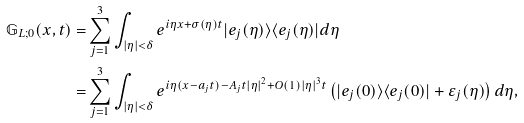<formula> <loc_0><loc_0><loc_500><loc_500>\mathbb { G } _ { L ; 0 } ( x , t ) = & \sum _ { j = 1 } ^ { 3 } \int _ { | \eta | < \delta } e ^ { i \eta x + \sigma ( \eta ) t } | e _ { j } ( \eta ) \rangle \langle e _ { j } ( \eta ) | d \eta \\ = & \sum _ { j = 1 } ^ { 3 } \int _ { | \eta | < \delta } e ^ { i \eta ( x - a _ { j } t ) - A _ { j } t | \eta | ^ { 2 } + O ( 1 ) | \eta | ^ { 3 } t } \left ( | e _ { j } ( 0 ) \rangle \langle e _ { j } ( 0 ) | + \varepsilon _ { j } ( \eta ) \right ) d \eta ,</formula> 